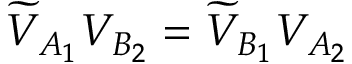<formula> <loc_0><loc_0><loc_500><loc_500>\widetilde { V } _ { A _ { 1 } } { V } _ { B _ { 2 } } = \widetilde { V } _ { B _ { 1 } } V _ { A _ { 2 } }</formula> 